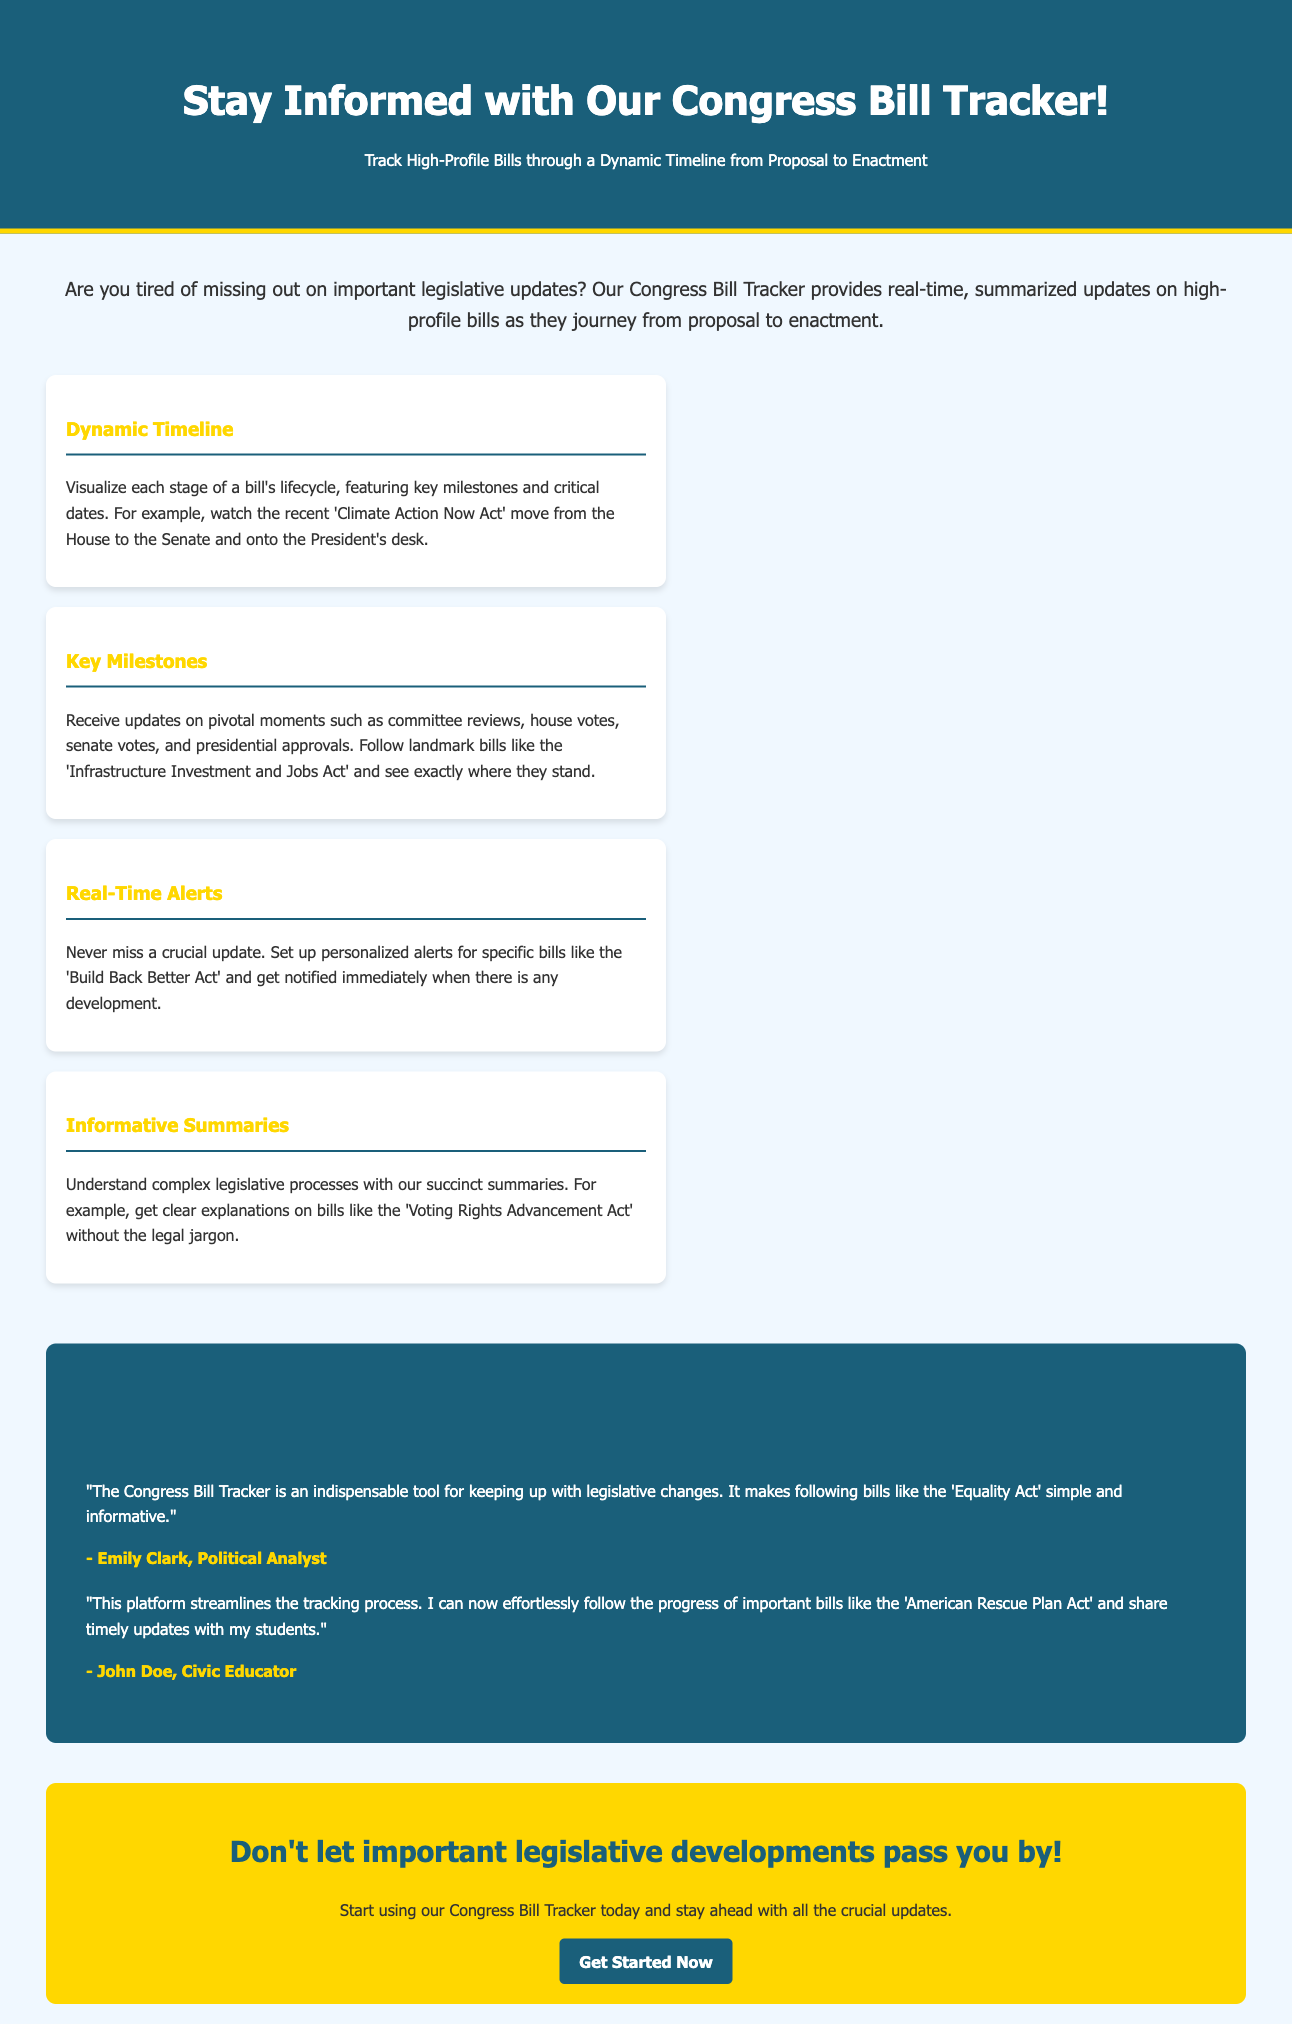What is the title of the advertisement? The title is stated prominently at the top of the document, calling attention to the primary service offered.
Answer: Stay Informed with Our Congress Bill Tracker! What type of timeline does the Congress Bill Tracker provide? The document mentions a specific feature that allows users to visualize the progress of bills through a timeline.
Answer: Dynamic Timeline Which act is used as an example of a bill moving through the legislative process? The document provides a specific example of a bill to illustrate the service being advertised.
Answer: Climate Action Now Act What alert feature does the Congress Bill Tracker offer? The document describes a functionality that allows users to be notified about specific legislative updates.
Answer: Real-Time Alerts Who is a testimonial author mentioned in the document? The testimonials section names individuals who have provided feedback on the service.
Answer: Emily Clark What color scheme is used in the header of the advertisement? The advertisement describes the colors employed for the header to create visual appeal.
Answer: #1a5f7a and white What is the main goal of the Congress Bill Tracker? The introduction of the document outlines the primary purpose for potential users of the tracker service.
Answer: Stay ahead with all the crucial updates How can users start using the Congress Bill Tracker? The call to action at the end of the advertisement provides guidance on what to do next for interested users.
Answer: Get Started Now 